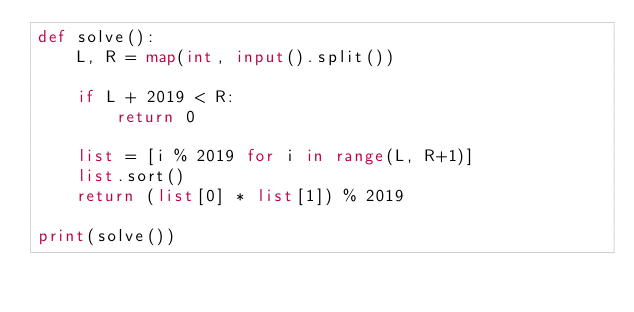<code> <loc_0><loc_0><loc_500><loc_500><_Python_>def solve():
    L, R = map(int, input().split())

    if L + 2019 < R:
        return 0
    
    list = [i % 2019 for i in range(L, R+1)]
    list.sort()
    return (list[0] * list[1]) % 2019

print(solve())
</code> 